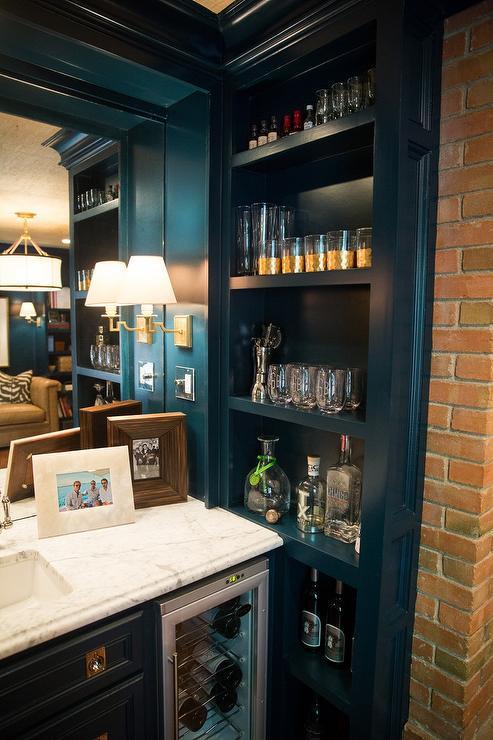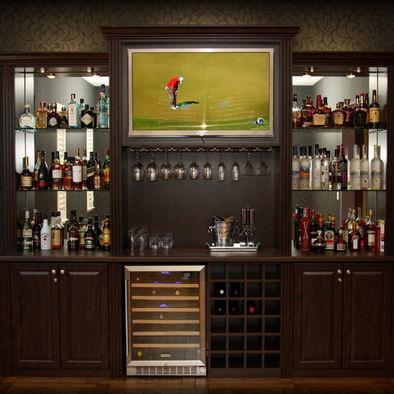The first image is the image on the left, the second image is the image on the right. Considering the images on both sides, is "A lamp is on in one of the images." valid? Answer yes or no. Yes. The first image is the image on the left, the second image is the image on the right. Considering the images on both sides, is "in at least one image in the middle of a dark wall bookshelf is a wide tv." valid? Answer yes or no. Yes. 